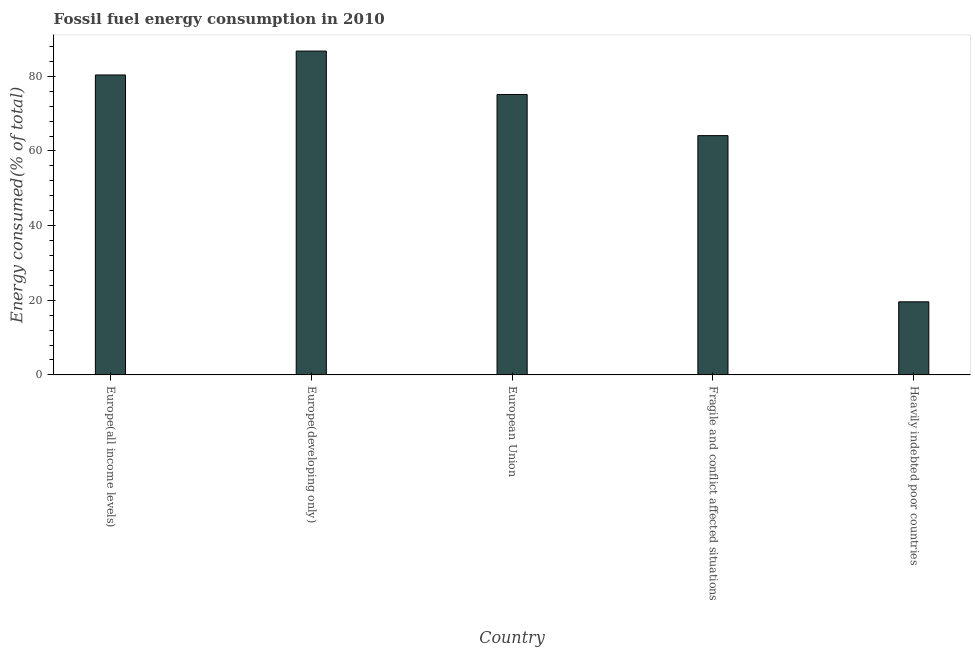Does the graph contain any zero values?
Offer a terse response. No. What is the title of the graph?
Keep it short and to the point. Fossil fuel energy consumption in 2010. What is the label or title of the Y-axis?
Provide a short and direct response. Energy consumed(% of total). What is the fossil fuel energy consumption in Heavily indebted poor countries?
Offer a terse response. 19.58. Across all countries, what is the maximum fossil fuel energy consumption?
Your response must be concise. 86.77. Across all countries, what is the minimum fossil fuel energy consumption?
Offer a terse response. 19.58. In which country was the fossil fuel energy consumption maximum?
Give a very brief answer. Europe(developing only). In which country was the fossil fuel energy consumption minimum?
Keep it short and to the point. Heavily indebted poor countries. What is the sum of the fossil fuel energy consumption?
Keep it short and to the point. 325.96. What is the difference between the fossil fuel energy consumption in Europe(developing only) and Fragile and conflict affected situations?
Your answer should be compact. 22.66. What is the average fossil fuel energy consumption per country?
Offer a very short reply. 65.19. What is the median fossil fuel energy consumption?
Make the answer very short. 75.14. In how many countries, is the fossil fuel energy consumption greater than 40 %?
Keep it short and to the point. 4. What is the ratio of the fossil fuel energy consumption in Europe(developing only) to that in Heavily indebted poor countries?
Give a very brief answer. 4.43. What is the difference between the highest and the second highest fossil fuel energy consumption?
Provide a short and direct response. 6.4. What is the difference between the highest and the lowest fossil fuel energy consumption?
Your response must be concise. 67.18. How many countries are there in the graph?
Keep it short and to the point. 5. What is the difference between two consecutive major ticks on the Y-axis?
Offer a terse response. 20. What is the Energy consumed(% of total) in Europe(all income levels)?
Offer a very short reply. 80.36. What is the Energy consumed(% of total) in Europe(developing only)?
Ensure brevity in your answer.  86.77. What is the Energy consumed(% of total) in European Union?
Your answer should be very brief. 75.14. What is the Energy consumed(% of total) in Fragile and conflict affected situations?
Make the answer very short. 64.11. What is the Energy consumed(% of total) in Heavily indebted poor countries?
Provide a succinct answer. 19.58. What is the difference between the Energy consumed(% of total) in Europe(all income levels) and Europe(developing only)?
Keep it short and to the point. -6.4. What is the difference between the Energy consumed(% of total) in Europe(all income levels) and European Union?
Provide a succinct answer. 5.23. What is the difference between the Energy consumed(% of total) in Europe(all income levels) and Fragile and conflict affected situations?
Provide a short and direct response. 16.25. What is the difference between the Energy consumed(% of total) in Europe(all income levels) and Heavily indebted poor countries?
Your answer should be very brief. 60.78. What is the difference between the Energy consumed(% of total) in Europe(developing only) and European Union?
Provide a succinct answer. 11.63. What is the difference between the Energy consumed(% of total) in Europe(developing only) and Fragile and conflict affected situations?
Your answer should be very brief. 22.66. What is the difference between the Energy consumed(% of total) in Europe(developing only) and Heavily indebted poor countries?
Your answer should be very brief. 67.18. What is the difference between the Energy consumed(% of total) in European Union and Fragile and conflict affected situations?
Offer a terse response. 11.03. What is the difference between the Energy consumed(% of total) in European Union and Heavily indebted poor countries?
Keep it short and to the point. 55.55. What is the difference between the Energy consumed(% of total) in Fragile and conflict affected situations and Heavily indebted poor countries?
Give a very brief answer. 44.53. What is the ratio of the Energy consumed(% of total) in Europe(all income levels) to that in Europe(developing only)?
Your answer should be compact. 0.93. What is the ratio of the Energy consumed(% of total) in Europe(all income levels) to that in European Union?
Give a very brief answer. 1.07. What is the ratio of the Energy consumed(% of total) in Europe(all income levels) to that in Fragile and conflict affected situations?
Offer a very short reply. 1.25. What is the ratio of the Energy consumed(% of total) in Europe(all income levels) to that in Heavily indebted poor countries?
Provide a short and direct response. 4.1. What is the ratio of the Energy consumed(% of total) in Europe(developing only) to that in European Union?
Your answer should be compact. 1.16. What is the ratio of the Energy consumed(% of total) in Europe(developing only) to that in Fragile and conflict affected situations?
Ensure brevity in your answer.  1.35. What is the ratio of the Energy consumed(% of total) in Europe(developing only) to that in Heavily indebted poor countries?
Ensure brevity in your answer.  4.43. What is the ratio of the Energy consumed(% of total) in European Union to that in Fragile and conflict affected situations?
Your answer should be compact. 1.17. What is the ratio of the Energy consumed(% of total) in European Union to that in Heavily indebted poor countries?
Your answer should be very brief. 3.84. What is the ratio of the Energy consumed(% of total) in Fragile and conflict affected situations to that in Heavily indebted poor countries?
Keep it short and to the point. 3.27. 